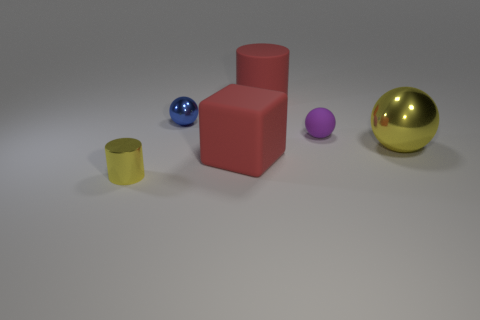Are there any green rubber spheres?
Your response must be concise. No. Does the cylinder in front of the big cylinder have the same material as the yellow object that is behind the tiny metallic cylinder?
Your answer should be very brief. Yes. What is the size of the metal thing behind the large yellow object to the right of the red rubber thing that is behind the big sphere?
Provide a short and direct response. Small. How many large red cylinders are made of the same material as the red cube?
Offer a terse response. 1. Is the number of green cubes less than the number of small blue objects?
Offer a very short reply. Yes. What is the size of the yellow shiny thing that is the same shape as the blue object?
Your answer should be very brief. Large. Does the cylinder that is behind the blue object have the same material as the large red block?
Give a very brief answer. Yes. Is the shape of the tiny blue object the same as the tiny yellow shiny thing?
Offer a very short reply. No. How many objects are tiny metallic objects that are in front of the tiny blue metallic thing or small objects?
Make the answer very short. 3. The red cylinder that is the same material as the cube is what size?
Provide a succinct answer. Large. 